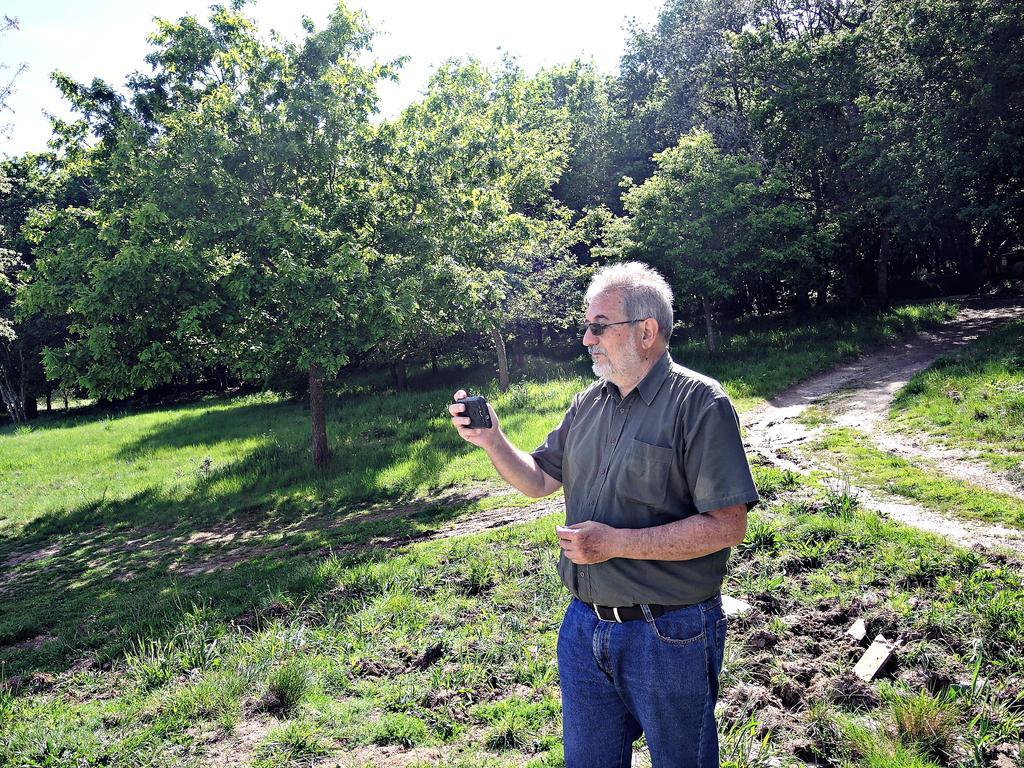Can you describe this image briefly? In the center of the image there is a person holding a phone in his hand. At the bottom of the image there is grass. In the background of the image there are trees. 